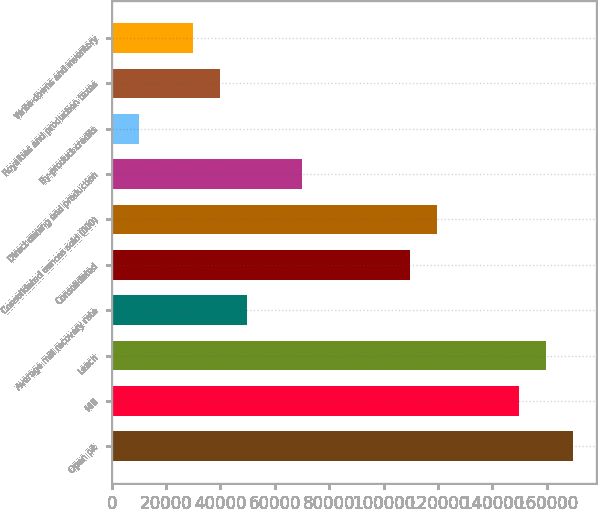Convert chart to OTSL. <chart><loc_0><loc_0><loc_500><loc_500><bar_chart><fcel>Open pit<fcel>Mill<fcel>Leach<fcel>Average mill recovery rate<fcel>Consolidated<fcel>Consolidated ounces sold (000)<fcel>Direct mining and production<fcel>By-product credits<fcel>Royalties and production taxes<fcel>Write-downs and inventory<nl><fcel>169648<fcel>149689<fcel>159669<fcel>49896.5<fcel>109772<fcel>119752<fcel>69855.1<fcel>9979.35<fcel>39917.2<fcel>29937.9<nl></chart> 